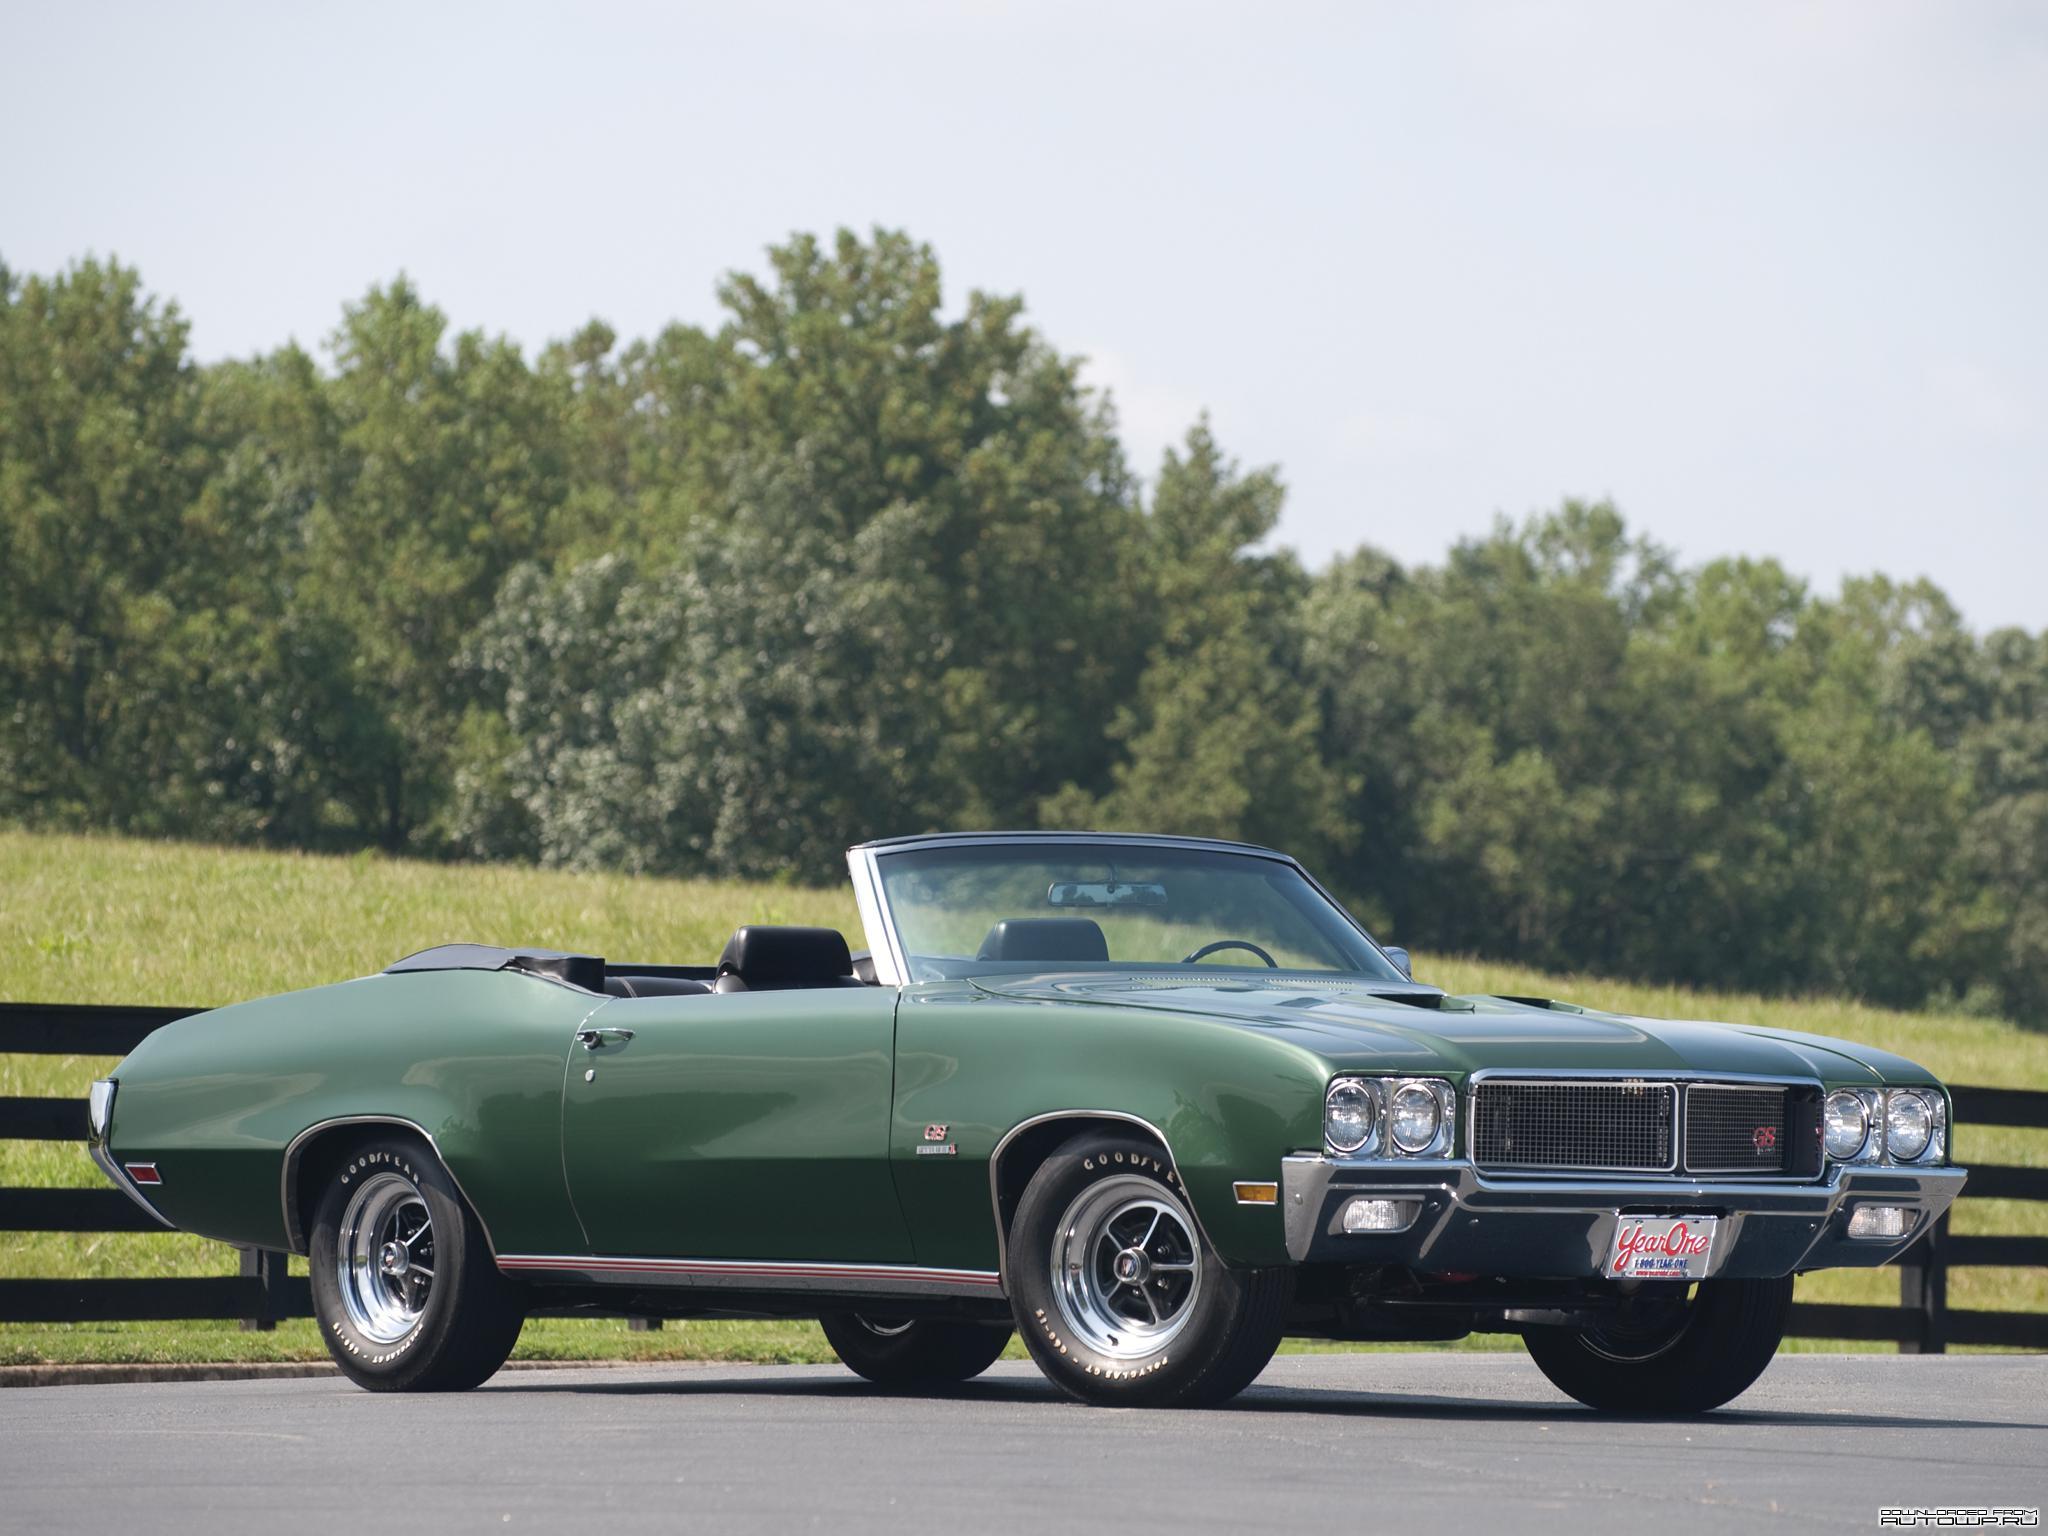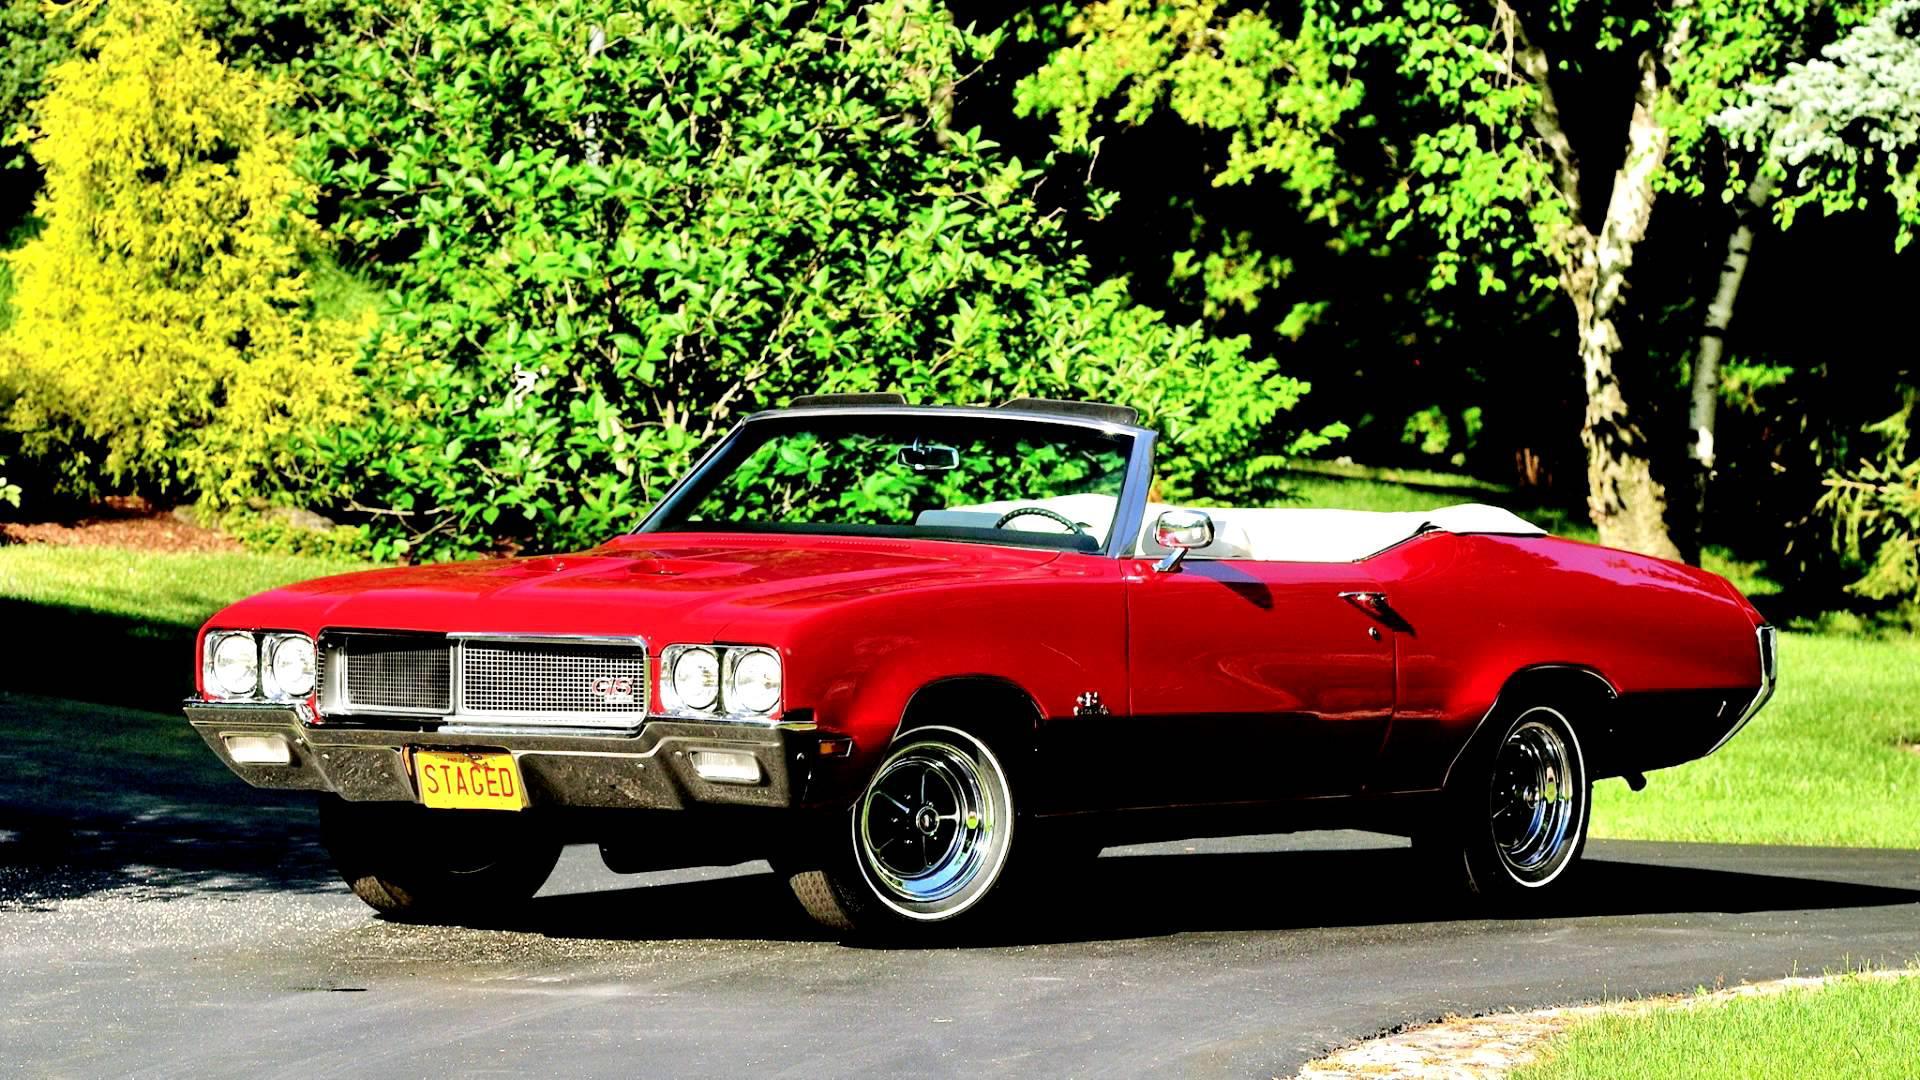The first image is the image on the left, the second image is the image on the right. Examine the images to the left and right. Is the description "The image on the right contains a red convertible." accurate? Answer yes or no. Yes. 